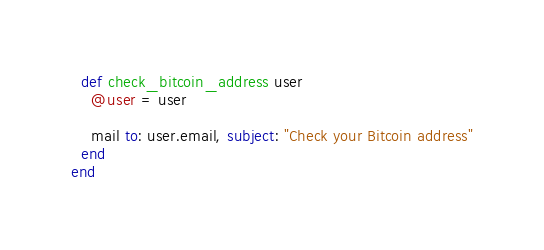Convert code to text. <code><loc_0><loc_0><loc_500><loc_500><_Ruby_>
  def check_bitcoin_address user
    @user = user

    mail to: user.email, subject: "Check your Bitcoin address"
  end
end
</code> 